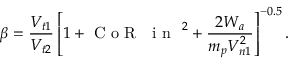<formula> <loc_0><loc_0><loc_500><loc_500>\beta = \frac { V _ { t 1 } } { V _ { t 2 } } \left [ 1 + C o R \text  subscript { i n } ^ { 2 } + \frac { 2 W _ { a } } { m _ { p } V _ { n 1 } ^ { 2 } } \right ] ^ { - 0 . 5 } .</formula> 